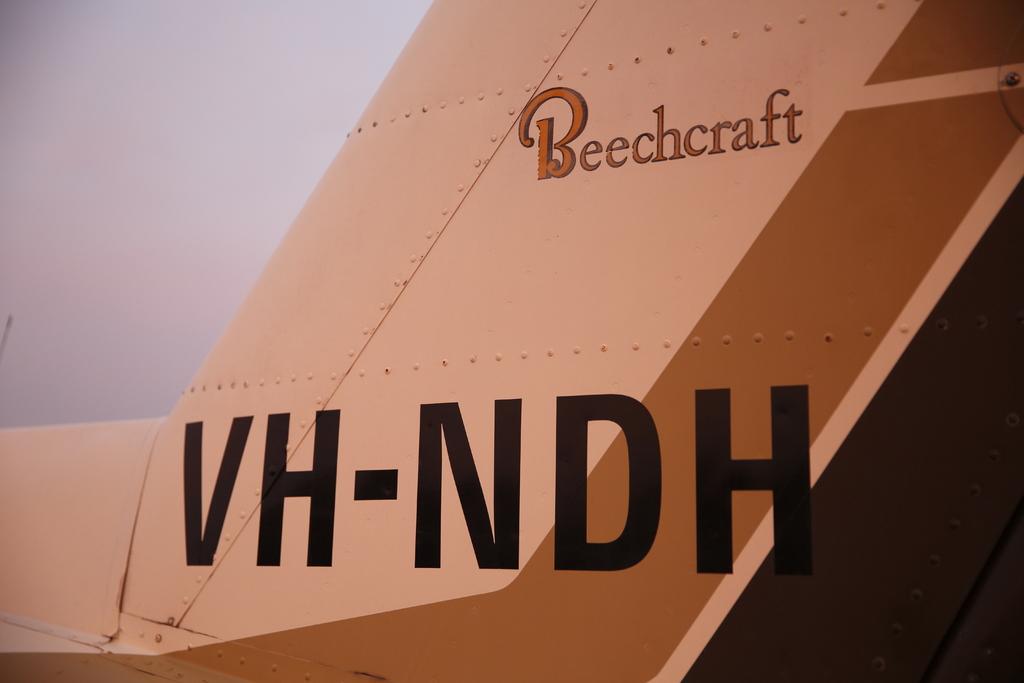What is the company on this plane?
Ensure brevity in your answer.  Beechcraft. What are the letters written on the tail of this plane?
Offer a very short reply. Vh-ndh. 